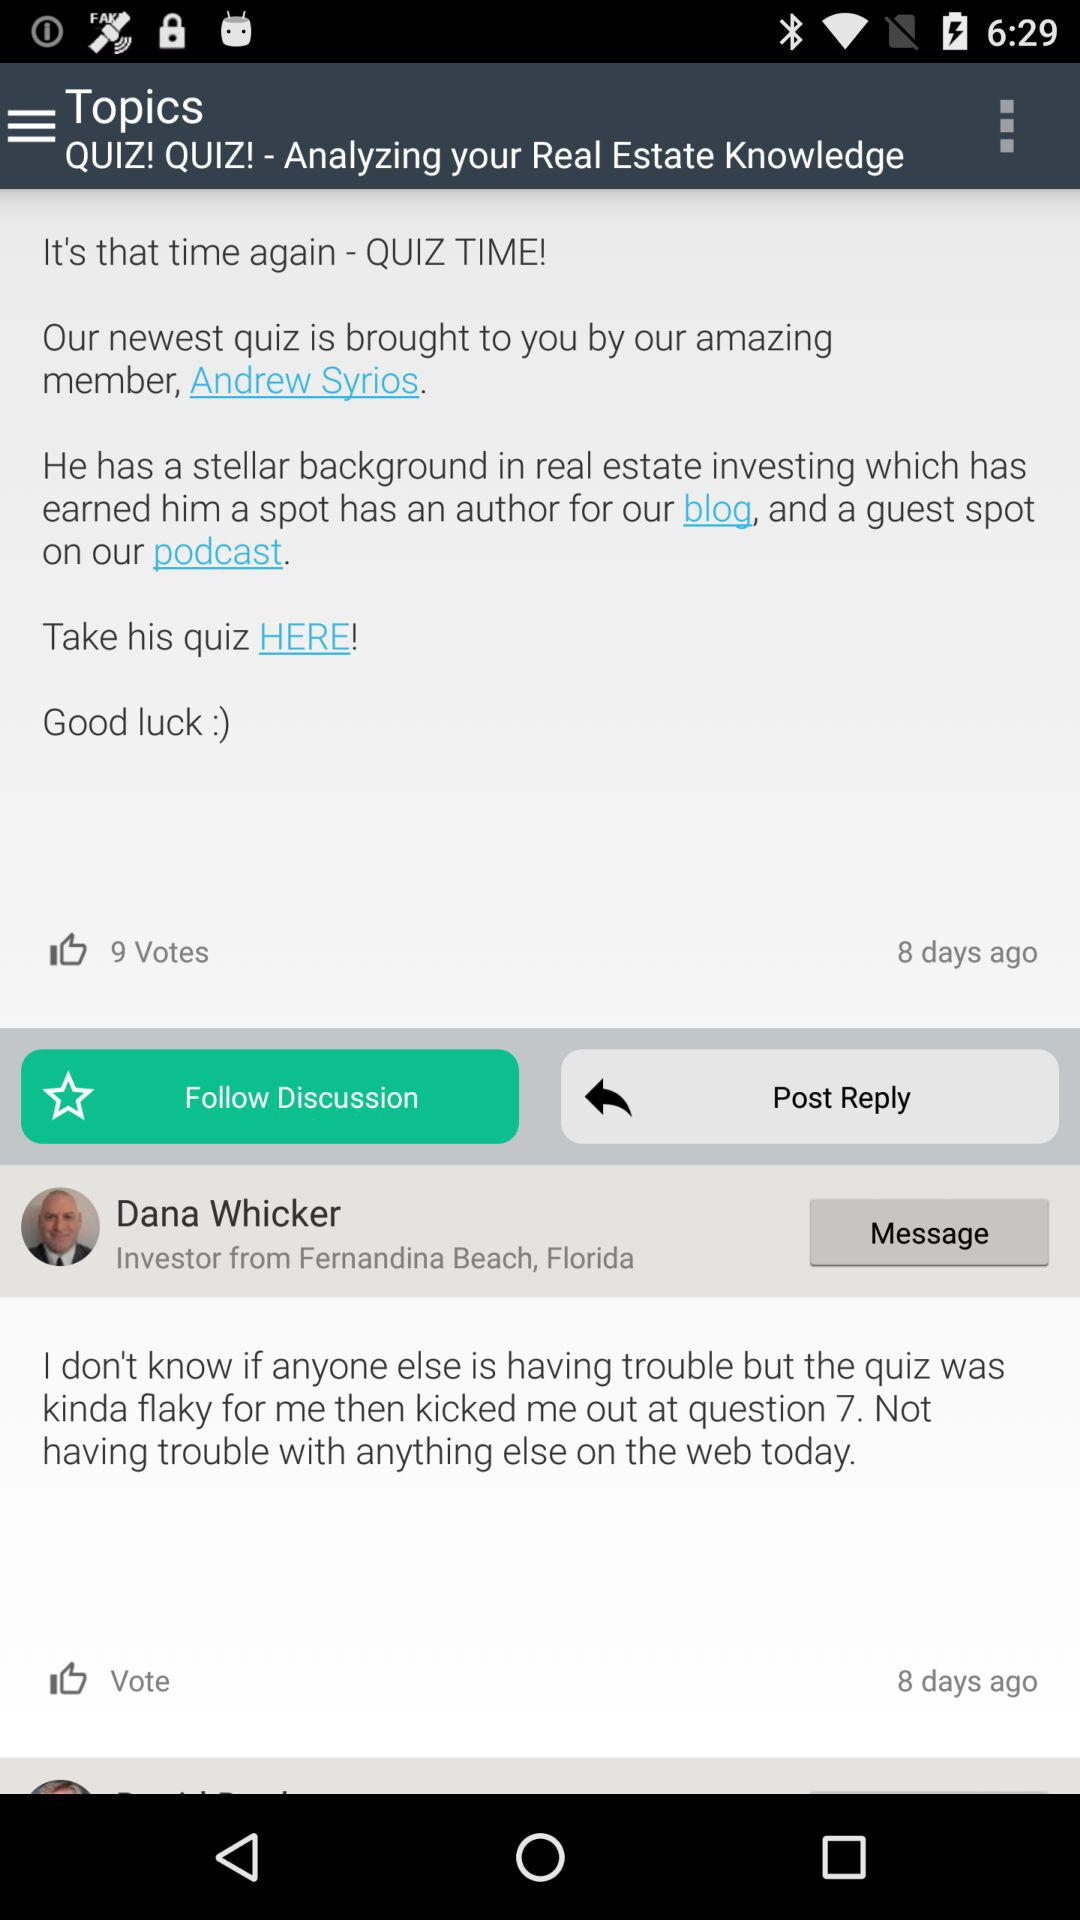What is the number of votes? The number of votes is 9. 